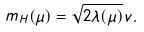Convert formula to latex. <formula><loc_0><loc_0><loc_500><loc_500>m _ { H } ( \mu ) = \sqrt { 2 \lambda ( \mu ) } v .</formula> 